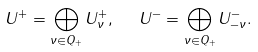Convert formula to latex. <formula><loc_0><loc_0><loc_500><loc_500>U ^ { + } = \bigoplus _ { \nu \in Q _ { + } } U ^ { + } _ { \nu } , \ \ U ^ { - } = \bigoplus _ { \nu \in Q _ { + } } U ^ { - } _ { - \nu } .</formula> 